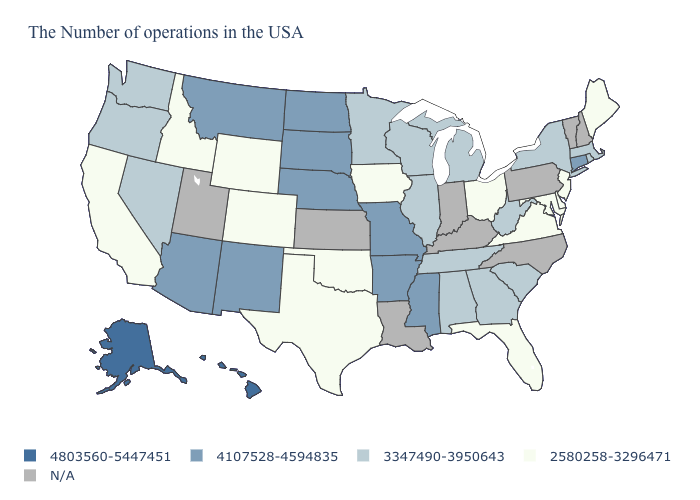Name the states that have a value in the range N/A?
Short answer required. New Hampshire, Vermont, Pennsylvania, North Carolina, Kentucky, Indiana, Louisiana, Kansas, Utah. What is the lowest value in states that border Rhode Island?
Answer briefly. 3347490-3950643. What is the value of Colorado?
Quick response, please. 2580258-3296471. Which states have the lowest value in the West?
Write a very short answer. Wyoming, Colorado, Idaho, California. What is the value of Utah?
Concise answer only. N/A. What is the value of Illinois?
Answer briefly. 3347490-3950643. What is the lowest value in the South?
Answer briefly. 2580258-3296471. Among the states that border Texas , which have the lowest value?
Write a very short answer. Oklahoma. What is the value of Virginia?
Be succinct. 2580258-3296471. What is the highest value in the MidWest ?
Concise answer only. 4107528-4594835. What is the value of Ohio?
Give a very brief answer. 2580258-3296471. What is the value of South Dakota?
Quick response, please. 4107528-4594835. Name the states that have a value in the range 4803560-5447451?
Quick response, please. Alaska, Hawaii. Does the map have missing data?
Be succinct. Yes. Name the states that have a value in the range 2580258-3296471?
Keep it brief. Maine, New Jersey, Delaware, Maryland, Virginia, Ohio, Florida, Iowa, Oklahoma, Texas, Wyoming, Colorado, Idaho, California. 